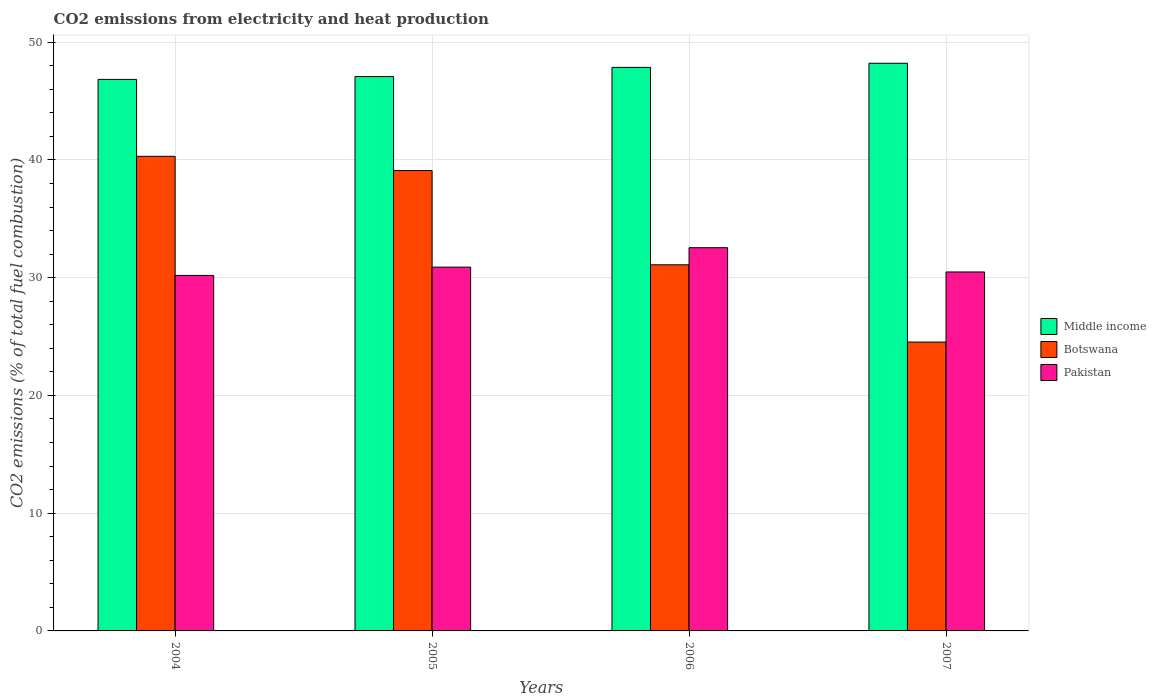How many different coloured bars are there?
Keep it short and to the point. 3. How many groups of bars are there?
Ensure brevity in your answer.  4. Are the number of bars per tick equal to the number of legend labels?
Offer a very short reply. Yes. Are the number of bars on each tick of the X-axis equal?
Offer a terse response. Yes. How many bars are there on the 1st tick from the right?
Your response must be concise. 3. What is the amount of CO2 emitted in Middle income in 2005?
Your response must be concise. 47.08. Across all years, what is the maximum amount of CO2 emitted in Middle income?
Your answer should be compact. 48.21. Across all years, what is the minimum amount of CO2 emitted in Pakistan?
Keep it short and to the point. 30.19. In which year was the amount of CO2 emitted in Pakistan minimum?
Your answer should be very brief. 2004. What is the total amount of CO2 emitted in Botswana in the graph?
Your answer should be very brief. 135.03. What is the difference between the amount of CO2 emitted in Middle income in 2006 and that in 2007?
Make the answer very short. -0.35. What is the difference between the amount of CO2 emitted in Botswana in 2007 and the amount of CO2 emitted in Pakistan in 2005?
Give a very brief answer. -6.36. What is the average amount of CO2 emitted in Pakistan per year?
Make the answer very short. 31.03. In the year 2007, what is the difference between the amount of CO2 emitted in Pakistan and amount of CO2 emitted in Middle income?
Provide a short and direct response. -17.72. In how many years, is the amount of CO2 emitted in Botswana greater than 40 %?
Offer a very short reply. 1. What is the ratio of the amount of CO2 emitted in Middle income in 2006 to that in 2007?
Keep it short and to the point. 0.99. Is the amount of CO2 emitted in Botswana in 2004 less than that in 2006?
Give a very brief answer. No. Is the difference between the amount of CO2 emitted in Pakistan in 2004 and 2007 greater than the difference between the amount of CO2 emitted in Middle income in 2004 and 2007?
Offer a very short reply. Yes. What is the difference between the highest and the second highest amount of CO2 emitted in Middle income?
Your response must be concise. 0.35. What is the difference between the highest and the lowest amount of CO2 emitted in Botswana?
Your answer should be compact. 15.77. What does the 2nd bar from the left in 2005 represents?
Give a very brief answer. Botswana. How many bars are there?
Your answer should be very brief. 12. Are all the bars in the graph horizontal?
Offer a very short reply. No. What is the difference between two consecutive major ticks on the Y-axis?
Offer a very short reply. 10. How many legend labels are there?
Offer a terse response. 3. What is the title of the graph?
Offer a terse response. CO2 emissions from electricity and heat production. Does "East Asia (developing only)" appear as one of the legend labels in the graph?
Give a very brief answer. No. What is the label or title of the Y-axis?
Give a very brief answer. CO2 emissions (% of total fuel combustion). What is the CO2 emissions (% of total fuel combustion) of Middle income in 2004?
Offer a very short reply. 46.84. What is the CO2 emissions (% of total fuel combustion) in Botswana in 2004?
Offer a terse response. 40.31. What is the CO2 emissions (% of total fuel combustion) of Pakistan in 2004?
Your answer should be compact. 30.19. What is the CO2 emissions (% of total fuel combustion) in Middle income in 2005?
Give a very brief answer. 47.08. What is the CO2 emissions (% of total fuel combustion) in Botswana in 2005?
Make the answer very short. 39.1. What is the CO2 emissions (% of total fuel combustion) of Pakistan in 2005?
Provide a short and direct response. 30.9. What is the CO2 emissions (% of total fuel combustion) in Middle income in 2006?
Your answer should be very brief. 47.86. What is the CO2 emissions (% of total fuel combustion) in Botswana in 2006?
Give a very brief answer. 31.09. What is the CO2 emissions (% of total fuel combustion) in Pakistan in 2006?
Offer a terse response. 32.55. What is the CO2 emissions (% of total fuel combustion) in Middle income in 2007?
Your answer should be very brief. 48.21. What is the CO2 emissions (% of total fuel combustion) in Botswana in 2007?
Your response must be concise. 24.53. What is the CO2 emissions (% of total fuel combustion) of Pakistan in 2007?
Your answer should be very brief. 30.48. Across all years, what is the maximum CO2 emissions (% of total fuel combustion) in Middle income?
Offer a terse response. 48.21. Across all years, what is the maximum CO2 emissions (% of total fuel combustion) of Botswana?
Offer a very short reply. 40.31. Across all years, what is the maximum CO2 emissions (% of total fuel combustion) in Pakistan?
Keep it short and to the point. 32.55. Across all years, what is the minimum CO2 emissions (% of total fuel combustion) of Middle income?
Your answer should be very brief. 46.84. Across all years, what is the minimum CO2 emissions (% of total fuel combustion) of Botswana?
Your answer should be compact. 24.53. Across all years, what is the minimum CO2 emissions (% of total fuel combustion) of Pakistan?
Make the answer very short. 30.19. What is the total CO2 emissions (% of total fuel combustion) of Middle income in the graph?
Your response must be concise. 189.99. What is the total CO2 emissions (% of total fuel combustion) in Botswana in the graph?
Offer a terse response. 135.03. What is the total CO2 emissions (% of total fuel combustion) of Pakistan in the graph?
Offer a very short reply. 124.12. What is the difference between the CO2 emissions (% of total fuel combustion) in Middle income in 2004 and that in 2005?
Provide a succinct answer. -0.24. What is the difference between the CO2 emissions (% of total fuel combustion) in Botswana in 2004 and that in 2005?
Make the answer very short. 1.21. What is the difference between the CO2 emissions (% of total fuel combustion) in Pakistan in 2004 and that in 2005?
Provide a short and direct response. -0.7. What is the difference between the CO2 emissions (% of total fuel combustion) of Middle income in 2004 and that in 2006?
Provide a succinct answer. -1.02. What is the difference between the CO2 emissions (% of total fuel combustion) of Botswana in 2004 and that in 2006?
Your response must be concise. 9.21. What is the difference between the CO2 emissions (% of total fuel combustion) of Pakistan in 2004 and that in 2006?
Provide a succinct answer. -2.35. What is the difference between the CO2 emissions (% of total fuel combustion) of Middle income in 2004 and that in 2007?
Your answer should be compact. -1.37. What is the difference between the CO2 emissions (% of total fuel combustion) of Botswana in 2004 and that in 2007?
Provide a short and direct response. 15.77. What is the difference between the CO2 emissions (% of total fuel combustion) in Pakistan in 2004 and that in 2007?
Provide a short and direct response. -0.29. What is the difference between the CO2 emissions (% of total fuel combustion) in Middle income in 2005 and that in 2006?
Make the answer very short. -0.78. What is the difference between the CO2 emissions (% of total fuel combustion) in Botswana in 2005 and that in 2006?
Ensure brevity in your answer.  8.01. What is the difference between the CO2 emissions (% of total fuel combustion) in Pakistan in 2005 and that in 2006?
Give a very brief answer. -1.65. What is the difference between the CO2 emissions (% of total fuel combustion) of Middle income in 2005 and that in 2007?
Give a very brief answer. -1.13. What is the difference between the CO2 emissions (% of total fuel combustion) of Botswana in 2005 and that in 2007?
Make the answer very short. 14.57. What is the difference between the CO2 emissions (% of total fuel combustion) of Pakistan in 2005 and that in 2007?
Keep it short and to the point. 0.41. What is the difference between the CO2 emissions (% of total fuel combustion) of Middle income in 2006 and that in 2007?
Provide a short and direct response. -0.35. What is the difference between the CO2 emissions (% of total fuel combustion) in Botswana in 2006 and that in 2007?
Provide a short and direct response. 6.56. What is the difference between the CO2 emissions (% of total fuel combustion) of Pakistan in 2006 and that in 2007?
Provide a short and direct response. 2.06. What is the difference between the CO2 emissions (% of total fuel combustion) of Middle income in 2004 and the CO2 emissions (% of total fuel combustion) of Botswana in 2005?
Give a very brief answer. 7.74. What is the difference between the CO2 emissions (% of total fuel combustion) in Middle income in 2004 and the CO2 emissions (% of total fuel combustion) in Pakistan in 2005?
Your response must be concise. 15.94. What is the difference between the CO2 emissions (% of total fuel combustion) of Botswana in 2004 and the CO2 emissions (% of total fuel combustion) of Pakistan in 2005?
Your answer should be compact. 9.41. What is the difference between the CO2 emissions (% of total fuel combustion) in Middle income in 2004 and the CO2 emissions (% of total fuel combustion) in Botswana in 2006?
Offer a terse response. 15.74. What is the difference between the CO2 emissions (% of total fuel combustion) in Middle income in 2004 and the CO2 emissions (% of total fuel combustion) in Pakistan in 2006?
Ensure brevity in your answer.  14.29. What is the difference between the CO2 emissions (% of total fuel combustion) in Botswana in 2004 and the CO2 emissions (% of total fuel combustion) in Pakistan in 2006?
Offer a terse response. 7.76. What is the difference between the CO2 emissions (% of total fuel combustion) in Middle income in 2004 and the CO2 emissions (% of total fuel combustion) in Botswana in 2007?
Your answer should be very brief. 22.31. What is the difference between the CO2 emissions (% of total fuel combustion) in Middle income in 2004 and the CO2 emissions (% of total fuel combustion) in Pakistan in 2007?
Offer a very short reply. 16.35. What is the difference between the CO2 emissions (% of total fuel combustion) of Botswana in 2004 and the CO2 emissions (% of total fuel combustion) of Pakistan in 2007?
Make the answer very short. 9.82. What is the difference between the CO2 emissions (% of total fuel combustion) of Middle income in 2005 and the CO2 emissions (% of total fuel combustion) of Botswana in 2006?
Offer a very short reply. 15.99. What is the difference between the CO2 emissions (% of total fuel combustion) in Middle income in 2005 and the CO2 emissions (% of total fuel combustion) in Pakistan in 2006?
Ensure brevity in your answer.  14.53. What is the difference between the CO2 emissions (% of total fuel combustion) in Botswana in 2005 and the CO2 emissions (% of total fuel combustion) in Pakistan in 2006?
Offer a terse response. 6.55. What is the difference between the CO2 emissions (% of total fuel combustion) of Middle income in 2005 and the CO2 emissions (% of total fuel combustion) of Botswana in 2007?
Ensure brevity in your answer.  22.55. What is the difference between the CO2 emissions (% of total fuel combustion) in Middle income in 2005 and the CO2 emissions (% of total fuel combustion) in Pakistan in 2007?
Provide a short and direct response. 16.6. What is the difference between the CO2 emissions (% of total fuel combustion) of Botswana in 2005 and the CO2 emissions (% of total fuel combustion) of Pakistan in 2007?
Your answer should be very brief. 8.61. What is the difference between the CO2 emissions (% of total fuel combustion) in Middle income in 2006 and the CO2 emissions (% of total fuel combustion) in Botswana in 2007?
Provide a short and direct response. 23.33. What is the difference between the CO2 emissions (% of total fuel combustion) of Middle income in 2006 and the CO2 emissions (% of total fuel combustion) of Pakistan in 2007?
Provide a succinct answer. 17.37. What is the difference between the CO2 emissions (% of total fuel combustion) of Botswana in 2006 and the CO2 emissions (% of total fuel combustion) of Pakistan in 2007?
Give a very brief answer. 0.61. What is the average CO2 emissions (% of total fuel combustion) in Middle income per year?
Offer a very short reply. 47.5. What is the average CO2 emissions (% of total fuel combustion) of Botswana per year?
Give a very brief answer. 33.76. What is the average CO2 emissions (% of total fuel combustion) in Pakistan per year?
Provide a succinct answer. 31.03. In the year 2004, what is the difference between the CO2 emissions (% of total fuel combustion) in Middle income and CO2 emissions (% of total fuel combustion) in Botswana?
Provide a succinct answer. 6.53. In the year 2004, what is the difference between the CO2 emissions (% of total fuel combustion) in Middle income and CO2 emissions (% of total fuel combustion) in Pakistan?
Your response must be concise. 16.65. In the year 2004, what is the difference between the CO2 emissions (% of total fuel combustion) of Botswana and CO2 emissions (% of total fuel combustion) of Pakistan?
Your answer should be very brief. 10.11. In the year 2005, what is the difference between the CO2 emissions (% of total fuel combustion) of Middle income and CO2 emissions (% of total fuel combustion) of Botswana?
Your response must be concise. 7.98. In the year 2005, what is the difference between the CO2 emissions (% of total fuel combustion) in Middle income and CO2 emissions (% of total fuel combustion) in Pakistan?
Give a very brief answer. 16.18. In the year 2005, what is the difference between the CO2 emissions (% of total fuel combustion) of Botswana and CO2 emissions (% of total fuel combustion) of Pakistan?
Give a very brief answer. 8.2. In the year 2006, what is the difference between the CO2 emissions (% of total fuel combustion) of Middle income and CO2 emissions (% of total fuel combustion) of Botswana?
Your response must be concise. 16.76. In the year 2006, what is the difference between the CO2 emissions (% of total fuel combustion) in Middle income and CO2 emissions (% of total fuel combustion) in Pakistan?
Your answer should be compact. 15.31. In the year 2006, what is the difference between the CO2 emissions (% of total fuel combustion) of Botswana and CO2 emissions (% of total fuel combustion) of Pakistan?
Provide a short and direct response. -1.45. In the year 2007, what is the difference between the CO2 emissions (% of total fuel combustion) of Middle income and CO2 emissions (% of total fuel combustion) of Botswana?
Provide a succinct answer. 23.68. In the year 2007, what is the difference between the CO2 emissions (% of total fuel combustion) in Middle income and CO2 emissions (% of total fuel combustion) in Pakistan?
Ensure brevity in your answer.  17.72. In the year 2007, what is the difference between the CO2 emissions (% of total fuel combustion) in Botswana and CO2 emissions (% of total fuel combustion) in Pakistan?
Offer a very short reply. -5.95. What is the ratio of the CO2 emissions (% of total fuel combustion) in Botswana in 2004 to that in 2005?
Keep it short and to the point. 1.03. What is the ratio of the CO2 emissions (% of total fuel combustion) in Pakistan in 2004 to that in 2005?
Your answer should be very brief. 0.98. What is the ratio of the CO2 emissions (% of total fuel combustion) in Middle income in 2004 to that in 2006?
Your answer should be very brief. 0.98. What is the ratio of the CO2 emissions (% of total fuel combustion) in Botswana in 2004 to that in 2006?
Your response must be concise. 1.3. What is the ratio of the CO2 emissions (% of total fuel combustion) of Pakistan in 2004 to that in 2006?
Your answer should be very brief. 0.93. What is the ratio of the CO2 emissions (% of total fuel combustion) of Middle income in 2004 to that in 2007?
Keep it short and to the point. 0.97. What is the ratio of the CO2 emissions (% of total fuel combustion) of Botswana in 2004 to that in 2007?
Make the answer very short. 1.64. What is the ratio of the CO2 emissions (% of total fuel combustion) of Middle income in 2005 to that in 2006?
Your answer should be compact. 0.98. What is the ratio of the CO2 emissions (% of total fuel combustion) of Botswana in 2005 to that in 2006?
Provide a short and direct response. 1.26. What is the ratio of the CO2 emissions (% of total fuel combustion) in Pakistan in 2005 to that in 2006?
Offer a terse response. 0.95. What is the ratio of the CO2 emissions (% of total fuel combustion) of Middle income in 2005 to that in 2007?
Ensure brevity in your answer.  0.98. What is the ratio of the CO2 emissions (% of total fuel combustion) of Botswana in 2005 to that in 2007?
Provide a succinct answer. 1.59. What is the ratio of the CO2 emissions (% of total fuel combustion) of Pakistan in 2005 to that in 2007?
Give a very brief answer. 1.01. What is the ratio of the CO2 emissions (% of total fuel combustion) of Middle income in 2006 to that in 2007?
Your answer should be compact. 0.99. What is the ratio of the CO2 emissions (% of total fuel combustion) in Botswana in 2006 to that in 2007?
Offer a terse response. 1.27. What is the ratio of the CO2 emissions (% of total fuel combustion) of Pakistan in 2006 to that in 2007?
Offer a very short reply. 1.07. What is the difference between the highest and the second highest CO2 emissions (% of total fuel combustion) in Middle income?
Your answer should be very brief. 0.35. What is the difference between the highest and the second highest CO2 emissions (% of total fuel combustion) in Botswana?
Make the answer very short. 1.21. What is the difference between the highest and the second highest CO2 emissions (% of total fuel combustion) of Pakistan?
Your answer should be compact. 1.65. What is the difference between the highest and the lowest CO2 emissions (% of total fuel combustion) in Middle income?
Keep it short and to the point. 1.37. What is the difference between the highest and the lowest CO2 emissions (% of total fuel combustion) of Botswana?
Your answer should be very brief. 15.77. What is the difference between the highest and the lowest CO2 emissions (% of total fuel combustion) in Pakistan?
Your answer should be compact. 2.35. 